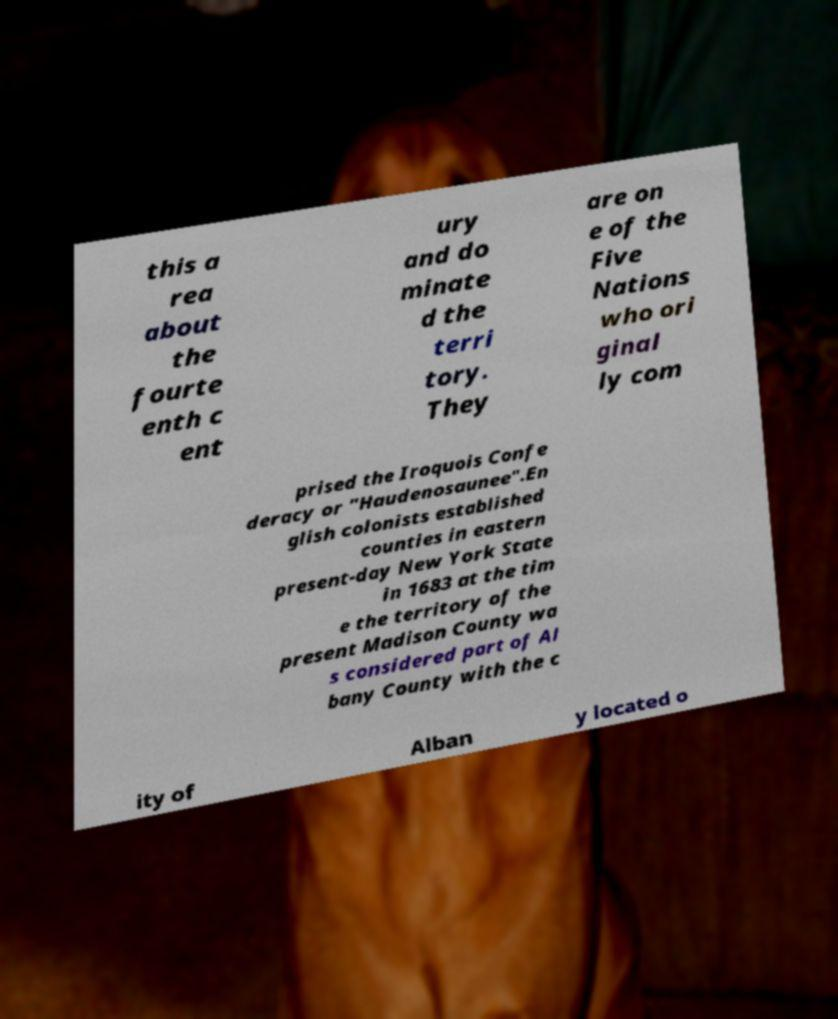Can you accurately transcribe the text from the provided image for me? this a rea about the fourte enth c ent ury and do minate d the terri tory. They are on e of the Five Nations who ori ginal ly com prised the Iroquois Confe deracy or "Haudenosaunee".En glish colonists established counties in eastern present-day New York State in 1683 at the tim e the territory of the present Madison County wa s considered part of Al bany County with the c ity of Alban y located o 